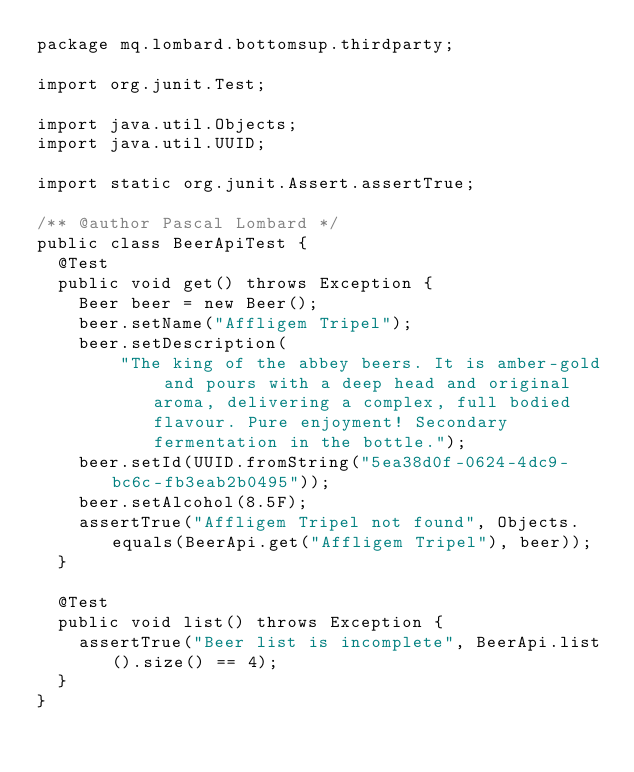Convert code to text. <code><loc_0><loc_0><loc_500><loc_500><_Java_>package mq.lombard.bottomsup.thirdparty;

import org.junit.Test;

import java.util.Objects;
import java.util.UUID;

import static org.junit.Assert.assertTrue;

/** @author Pascal Lombard */
public class BeerApiTest {
  @Test
  public void get() throws Exception {
    Beer beer = new Beer();
    beer.setName("Affligem Tripel");
    beer.setDescription(
        "The king of the abbey beers. It is amber-gold and pours with a deep head and original aroma, delivering a complex, full bodied flavour. Pure enjoyment! Secondary fermentation in the bottle.");
    beer.setId(UUID.fromString("5ea38d0f-0624-4dc9-bc6c-fb3eab2b0495"));
    beer.setAlcohol(8.5F);
    assertTrue("Affligem Tripel not found", Objects.equals(BeerApi.get("Affligem Tripel"), beer));
  }

  @Test
  public void list() throws Exception {
    assertTrue("Beer list is incomplete", BeerApi.list().size() == 4);
  }
}
</code> 